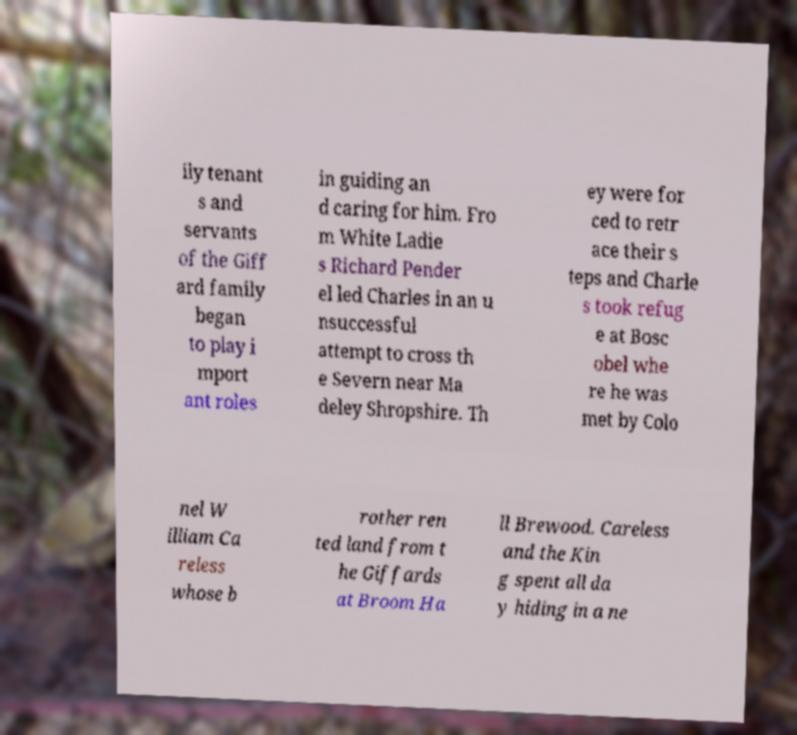Please identify and transcribe the text found in this image. ily tenant s and servants of the Giff ard family began to play i mport ant roles in guiding an d caring for him. Fro m White Ladie s Richard Pender el led Charles in an u nsuccessful attempt to cross th e Severn near Ma deley Shropshire. Th ey were for ced to retr ace their s teps and Charle s took refug e at Bosc obel whe re he was met by Colo nel W illiam Ca reless whose b rother ren ted land from t he Giffards at Broom Ha ll Brewood. Careless and the Kin g spent all da y hiding in a ne 